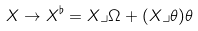<formula> <loc_0><loc_0><loc_500><loc_500>X \rightarrow X ^ { \flat } = X \lrcorner \Omega + ( X \lrcorner \theta ) \theta</formula> 